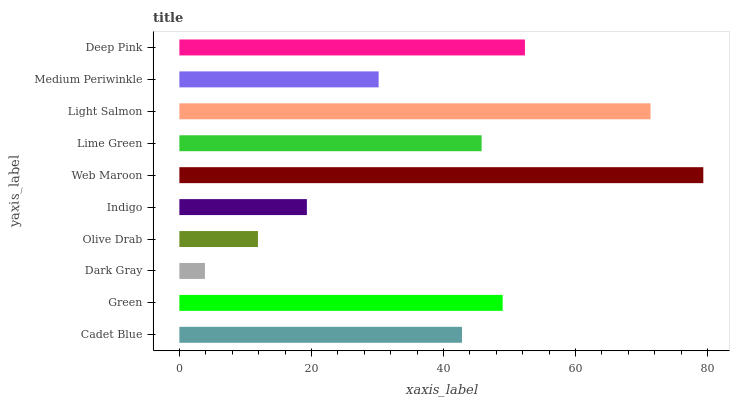Is Dark Gray the minimum?
Answer yes or no. Yes. Is Web Maroon the maximum?
Answer yes or no. Yes. Is Green the minimum?
Answer yes or no. No. Is Green the maximum?
Answer yes or no. No. Is Green greater than Cadet Blue?
Answer yes or no. Yes. Is Cadet Blue less than Green?
Answer yes or no. Yes. Is Cadet Blue greater than Green?
Answer yes or no. No. Is Green less than Cadet Blue?
Answer yes or no. No. Is Lime Green the high median?
Answer yes or no. Yes. Is Cadet Blue the low median?
Answer yes or no. Yes. Is Indigo the high median?
Answer yes or no. No. Is Medium Periwinkle the low median?
Answer yes or no. No. 